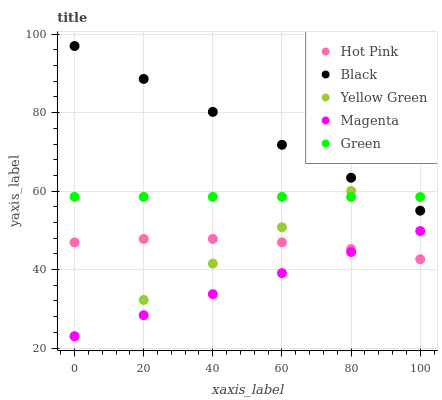Does Magenta have the minimum area under the curve?
Answer yes or no. Yes. Does Black have the maximum area under the curve?
Answer yes or no. Yes. Does Hot Pink have the minimum area under the curve?
Answer yes or no. No. Does Hot Pink have the maximum area under the curve?
Answer yes or no. No. Is Yellow Green the smoothest?
Answer yes or no. Yes. Is Hot Pink the roughest?
Answer yes or no. Yes. Is Magenta the smoothest?
Answer yes or no. No. Is Magenta the roughest?
Answer yes or no. No. Does Magenta have the lowest value?
Answer yes or no. Yes. Does Hot Pink have the lowest value?
Answer yes or no. No. Does Black have the highest value?
Answer yes or no. Yes. Does Magenta have the highest value?
Answer yes or no. No. Is Magenta less than Green?
Answer yes or no. Yes. Is Green greater than Hot Pink?
Answer yes or no. Yes. Does Magenta intersect Hot Pink?
Answer yes or no. Yes. Is Magenta less than Hot Pink?
Answer yes or no. No. Is Magenta greater than Hot Pink?
Answer yes or no. No. Does Magenta intersect Green?
Answer yes or no. No. 